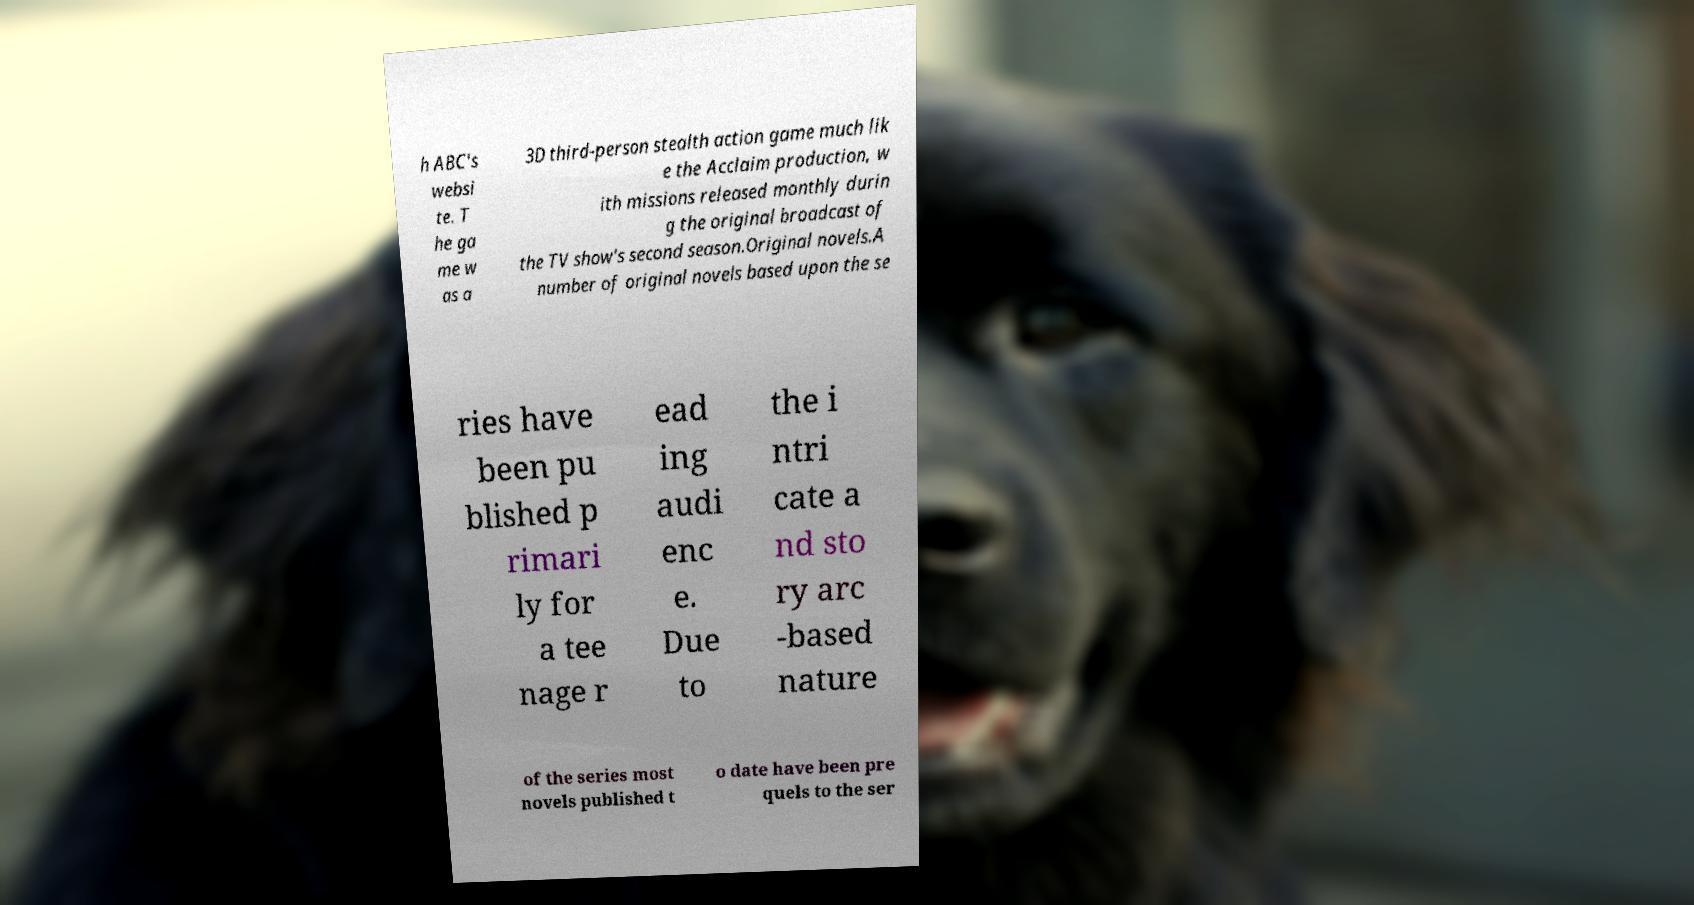Can you accurately transcribe the text from the provided image for me? h ABC's websi te. T he ga me w as a 3D third-person stealth action game much lik e the Acclaim production, w ith missions released monthly durin g the original broadcast of the TV show's second season.Original novels.A number of original novels based upon the se ries have been pu blished p rimari ly for a tee nage r ead ing audi enc e. Due to the i ntri cate a nd sto ry arc -based nature of the series most novels published t o date have been pre quels to the ser 